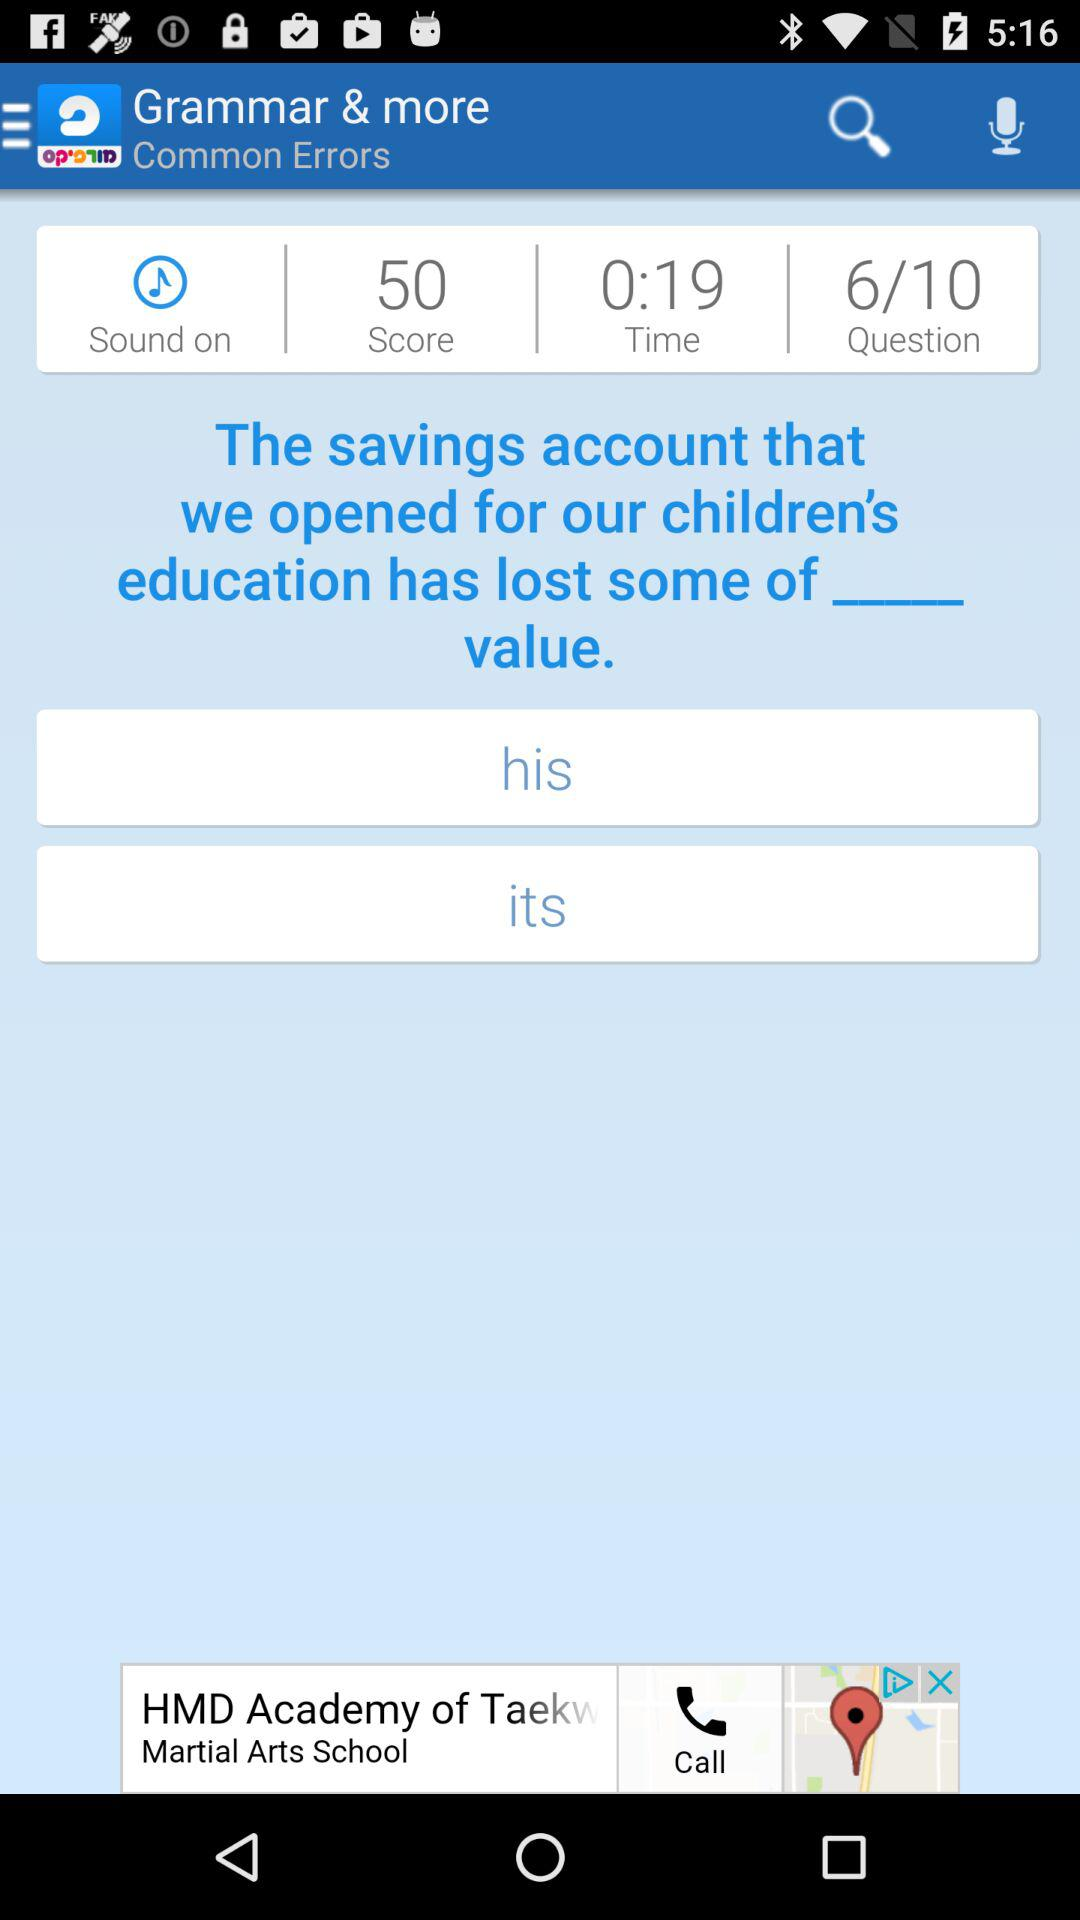Which question number are we currently on? You are currently on question number 6. 